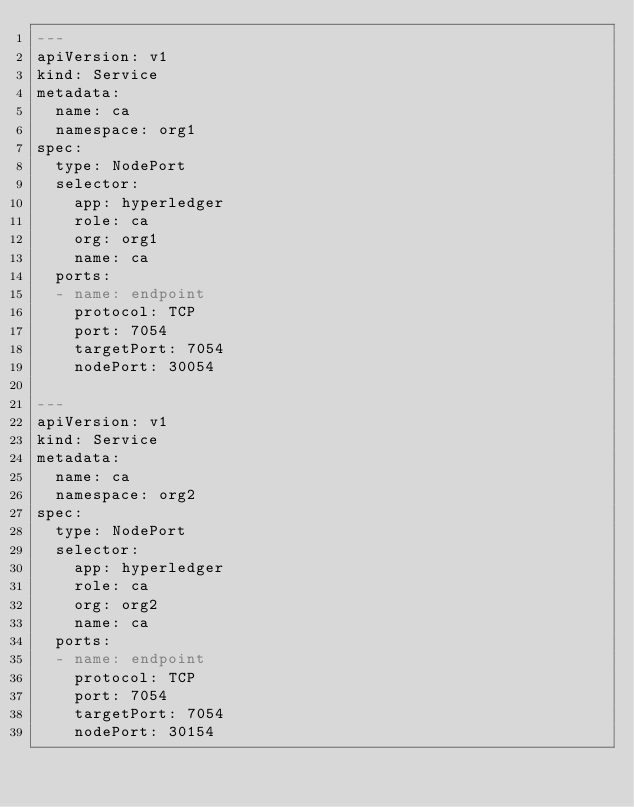Convert code to text. <code><loc_0><loc_0><loc_500><loc_500><_YAML_>---
apiVersion: v1
kind: Service
metadata:
  name: ca
  namespace: org1
spec:
  type: NodePort
  selector:
    app: hyperledger
    role: ca
    org: org1
    name: ca
  ports:
  - name: endpoint
    protocol: TCP
    port: 7054
    targetPort: 7054
    nodePort: 30054

---
apiVersion: v1
kind: Service
metadata:
  name: ca
  namespace: org2
spec:
  type: NodePort
  selector:
    app: hyperledger
    role: ca
    org: org2
    name: ca
  ports:
  - name: endpoint
    protocol: TCP
    port: 7054
    targetPort: 7054
    nodePort: 30154
</code> 